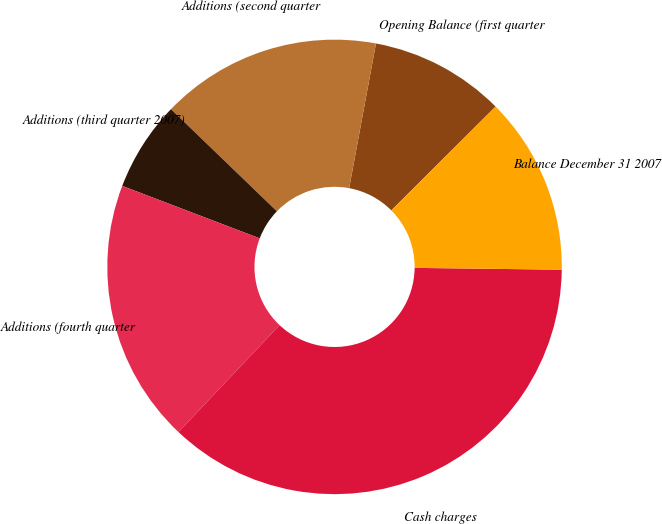<chart> <loc_0><loc_0><loc_500><loc_500><pie_chart><fcel>Opening Balance (first quarter<fcel>Additions (second quarter<fcel>Additions (third quarter 2007)<fcel>Additions (fourth quarter<fcel>Cash charges<fcel>Balance December 31 2007<nl><fcel>9.62%<fcel>15.71%<fcel>6.41%<fcel>18.75%<fcel>36.86%<fcel>12.66%<nl></chart> 